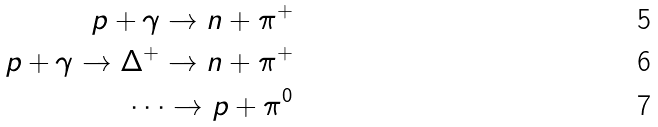Convert formula to latex. <formula><loc_0><loc_0><loc_500><loc_500>p + \gamma \rightarrow n + \pi ^ { + } \\ p + \gamma \rightarrow \Delta ^ { + } \rightarrow n + \pi ^ { + } \\ \dots \rightarrow p + \pi ^ { 0 }</formula> 